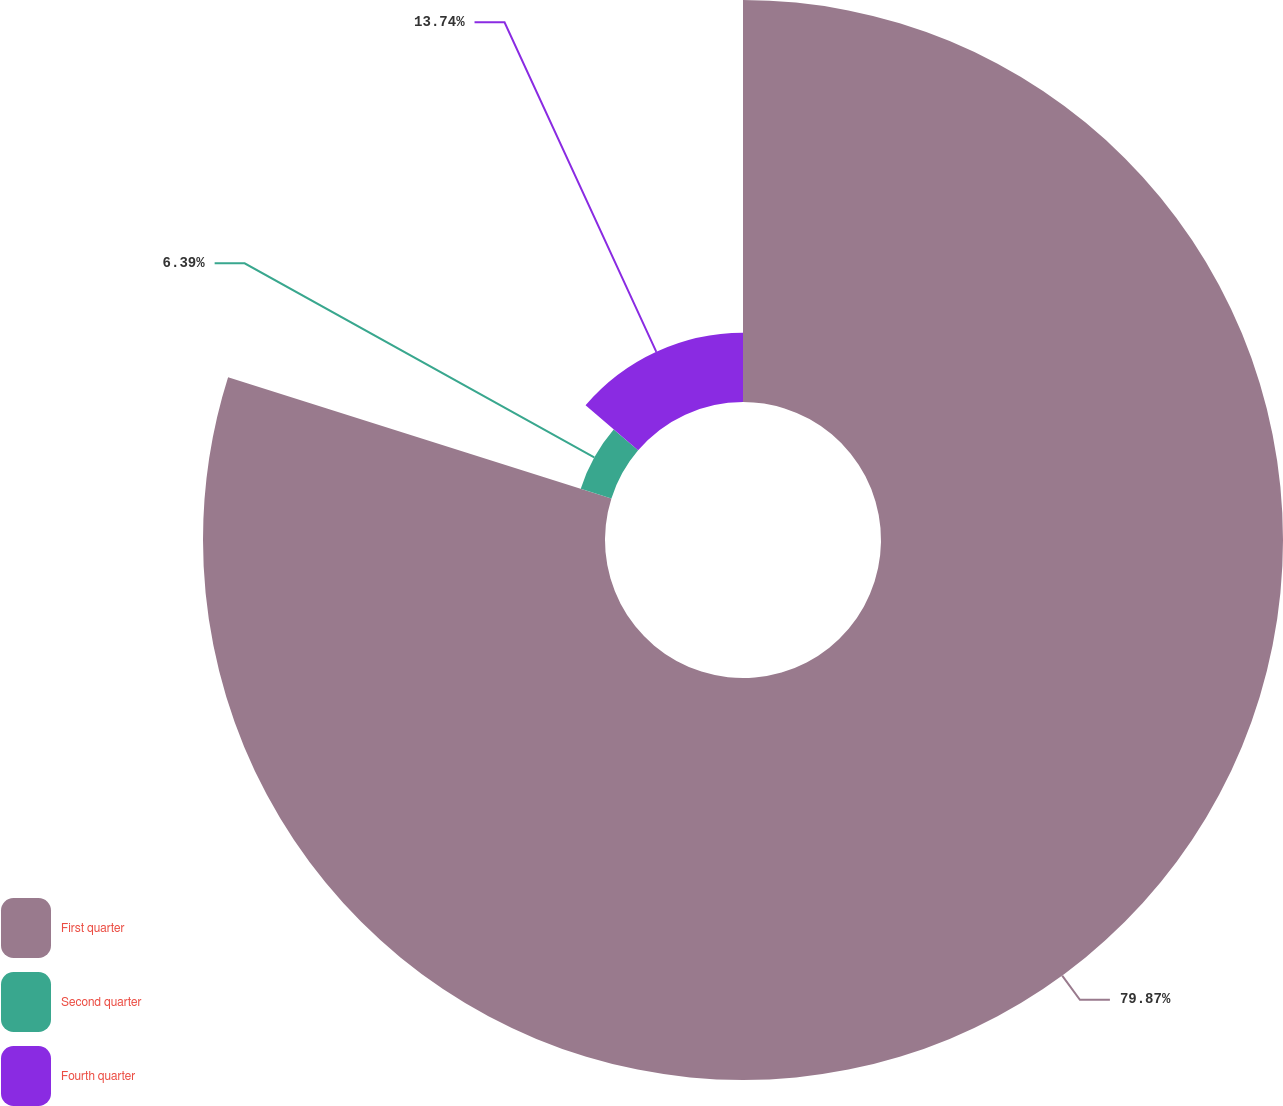Convert chart. <chart><loc_0><loc_0><loc_500><loc_500><pie_chart><fcel>First quarter<fcel>Second quarter<fcel>Fourth quarter<nl><fcel>79.87%<fcel>6.39%<fcel>13.74%<nl></chart> 